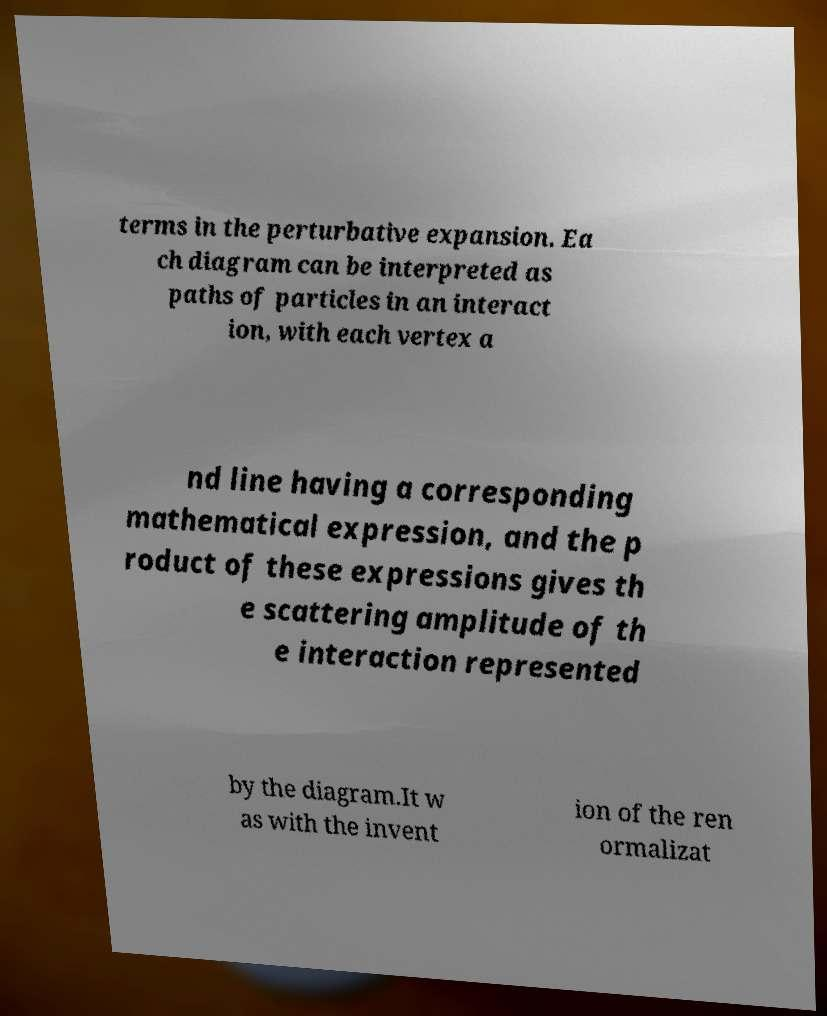Please identify and transcribe the text found in this image. terms in the perturbative expansion. Ea ch diagram can be interpreted as paths of particles in an interact ion, with each vertex a nd line having a corresponding mathematical expression, and the p roduct of these expressions gives th e scattering amplitude of th e interaction represented by the diagram.It w as with the invent ion of the ren ormalizat 